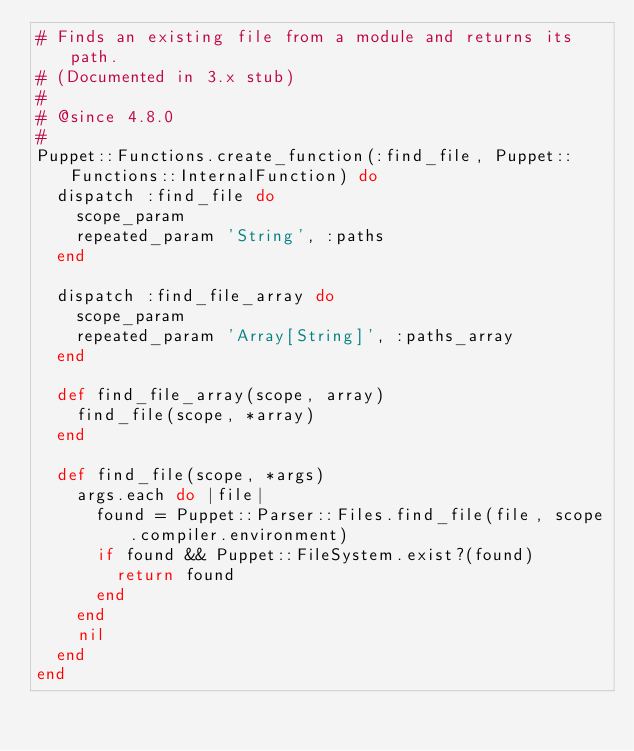<code> <loc_0><loc_0><loc_500><loc_500><_Ruby_># Finds an existing file from a module and returns its path.
# (Documented in 3.x stub)
#
# @since 4.8.0
#
Puppet::Functions.create_function(:find_file, Puppet::Functions::InternalFunction) do
  dispatch :find_file do
    scope_param
    repeated_param 'String', :paths
  end

  dispatch :find_file_array do
    scope_param
    repeated_param 'Array[String]', :paths_array
  end

  def find_file_array(scope, array)
    find_file(scope, *array)
  end

  def find_file(scope, *args)
    args.each do |file|
      found = Puppet::Parser::Files.find_file(file, scope.compiler.environment)
      if found && Puppet::FileSystem.exist?(found)
        return found
      end
    end
    nil
  end
end
</code> 